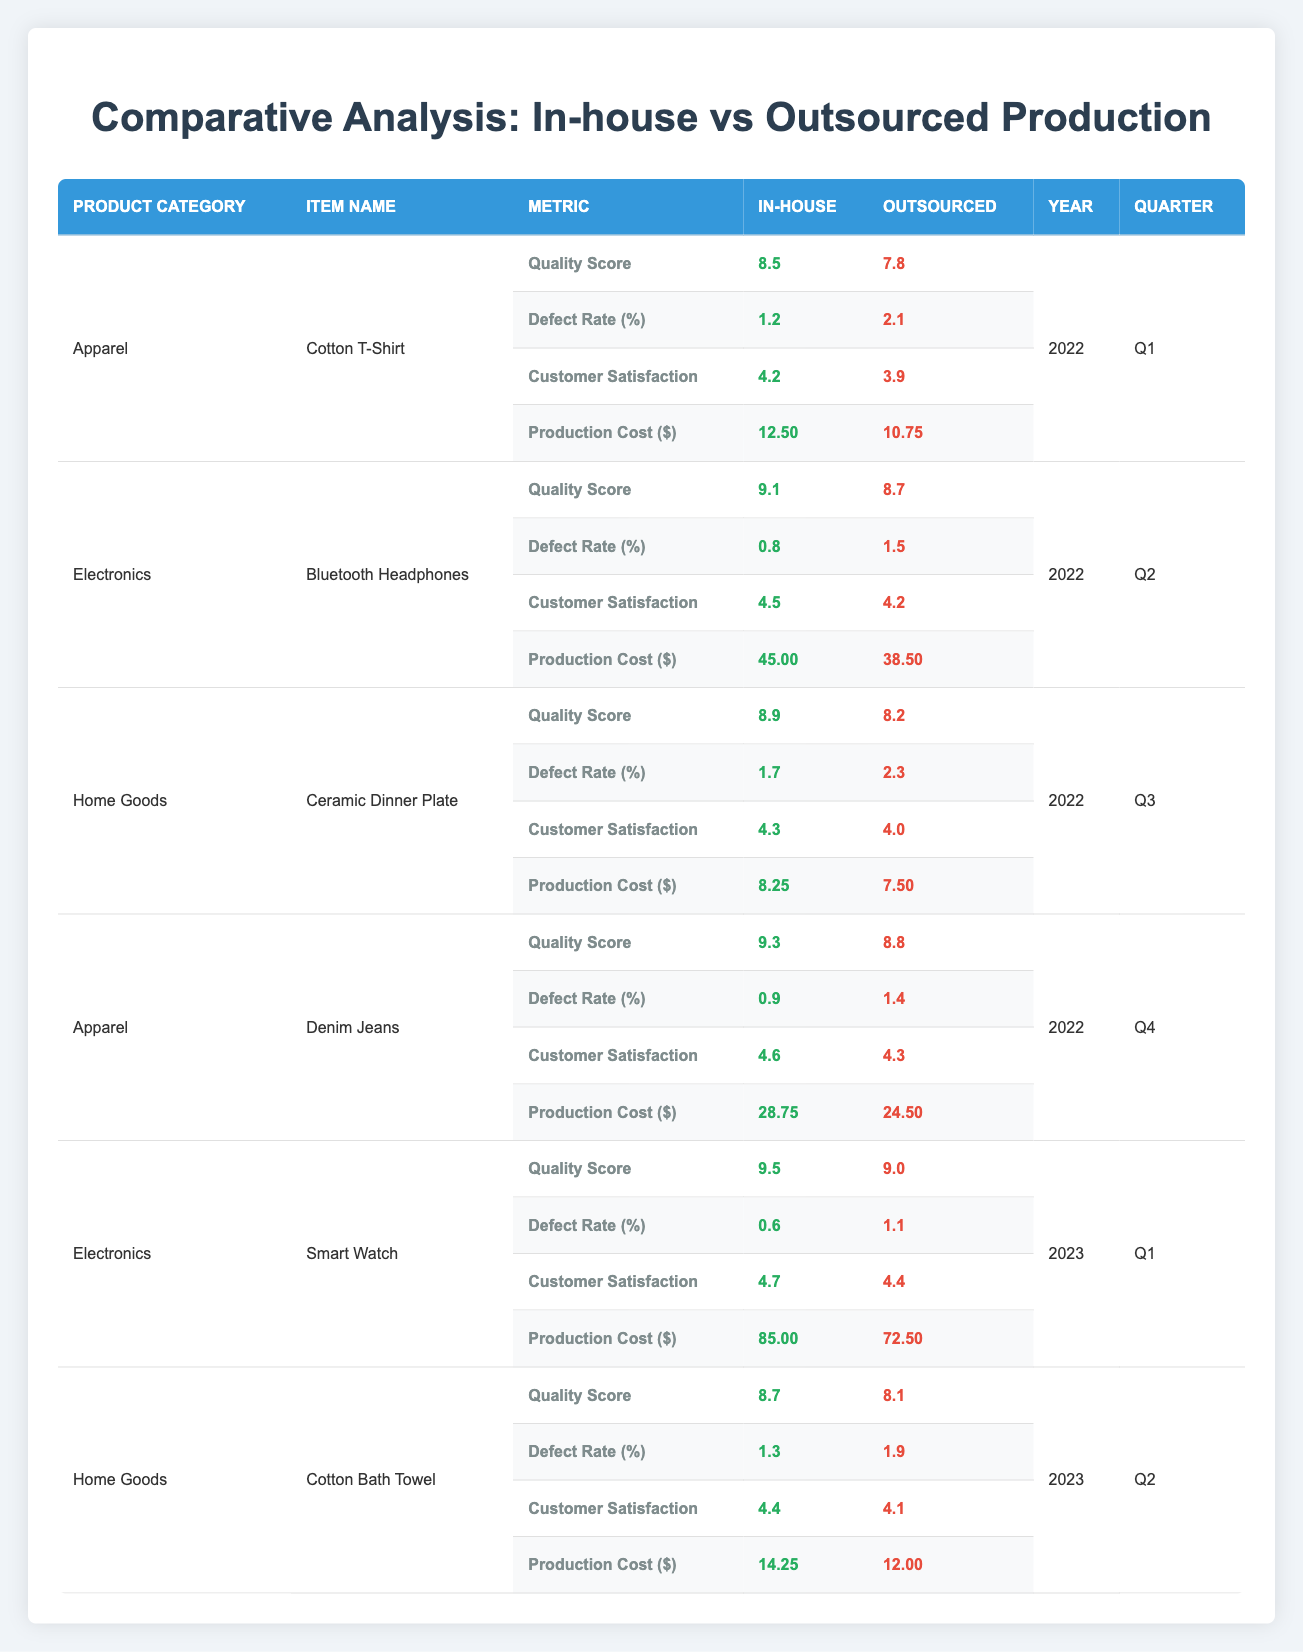What is the Quality Score for the Denim Jeans produced in-house? The table displays a row for Denim Jeans under the Apparel category, specifically indicating "Quality Score" for the in-house production, which is 9.3.
Answer: 9.3 What is the Defect Rate for the Bluetooth Headphones produced outsourced? The Bluetooth Headphones are listed under the Electronics category, and the row corresponding to outsourced production shows a Defect Rate of 1.5%.
Answer: 1.5 Which production type has a higher Customer Satisfaction score for the Cotton Bath Towel? For the Cotton Bath Towel, the Customer Satisfaction score for in-house production is 4.4, while for outsourced production, it is 4.1. Since 4.4 > 4.1, in-house production has a higher score.
Answer: In-house What is the average Production Cost for all in-house produced items listed? The Production Cost values for in-house items are 12.50, 45.00, 8.25, 28.75, 9.5, and 14.25. Summing these gives us 12.50 + 45.00 + 8.25 + 28.75 + 85.00 + 14.25 = 193.75, and dividing by 6 data points yields an average of 32.29.
Answer: 32.29 Is the average Quality Score for outsourced apparel higher than that for outsourced electronics? The average Quality Score for outsourced apparel (Cotton T-Shirt, 7.8 and Denim Jeans, 8.8) is (7.8 + 8.8) / 2 = 8.3. For outsourced electronics (Bluetooth Headphones, 8.7 and Smart Watch, 9.0), it is (8.7 + 9.0) / 2 = 8.85. Since 8.3 < 8.85, the average is not higher for apparel.
Answer: No Which product has the highest Customer Satisfaction score in the in-house category? Among in-house products, the scores are 4.2 (Cotton T-Shirt), 4.5 (Bluetooth Headphones), 4.3 (Ceramic Dinner Plate), 4.6 (Denim Jeans), 4.7 (Smart Watch), and 4.4 (Cotton Bath Towel). The highest score is 4.7 for the Smart Watch.
Answer: Smart Watch What is the Difference in Production Cost between in-house and outsourced for the Ceramic Dinner Plate? For the Ceramic Dinner Plate, the Production Cost for in-house is 8.25 and for outsourced is 7.50. The difference is 8.25 - 7.50 = 0.75.
Answer: 0.75 Does the Defect Rate for the in-house produced Smart Watch exceed 1%? The in-house Defect Rate for the Smart Watch is 0.6%, which is less than 1%. Therefore, it does not exceed 1%.
Answer: No 